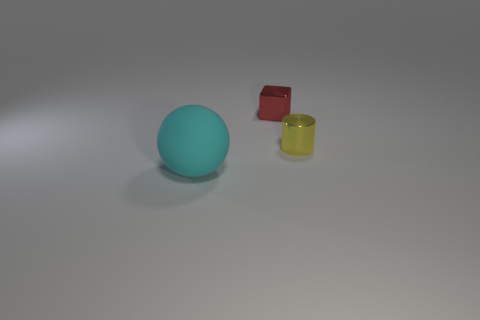How many other objects are there of the same shape as the yellow shiny object? There are no other objects of the same cylindrical shape as the yellow shiny object. In the image, aside from the yellow cylinder, there's a teal sphere and a red cube, each with a distinct shape. 